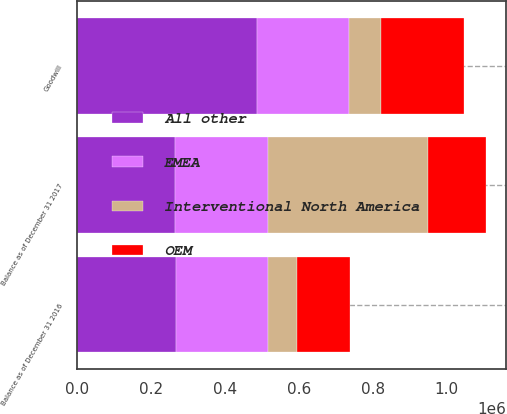<chart> <loc_0><loc_0><loc_500><loc_500><stacked_bar_chart><ecel><fcel>Goodwill<fcel>Balance as of December 31 2016<fcel>Balance as of December 31 2017<nl><fcel>All other<fcel>485986<fcel>266459<fcel>264869<nl><fcel>Interventional North America<fcel>84615<fcel>79087<fcel>433049<nl><fcel>OEM<fcel>225653<fcel>141253<fcel>157289<nl><fcel>EMEA<fcel>250912<fcel>250912<fcel>250912<nl></chart> 